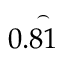<formula> <loc_0><loc_0><loc_500><loc_500>0 . { \overset { \frown } { 8 1 } }</formula> 